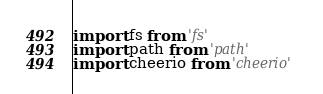<code> <loc_0><loc_0><loc_500><loc_500><_TypeScript_>import fs from 'fs'
import path from 'path'
import cheerio from 'cheerio'</code> 